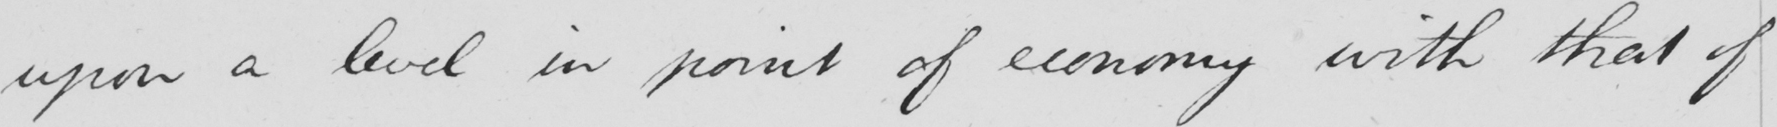Can you tell me what this handwritten text says? upon a level in point of economy with that of 